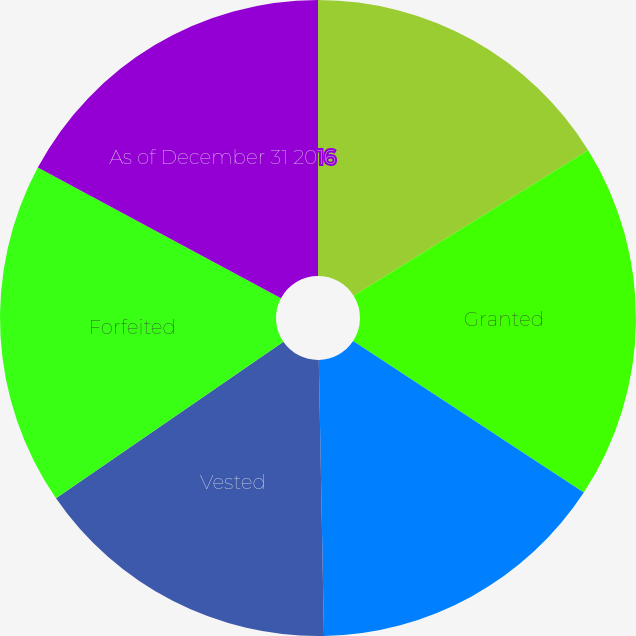Convert chart to OTSL. <chart><loc_0><loc_0><loc_500><loc_500><pie_chart><fcel>As of December 31 2015<fcel>Granted<fcel>Additional performance-based<fcel>Vested<fcel>Forfeited<fcel>As of December 31 2016<nl><fcel>16.16%<fcel>18.09%<fcel>15.45%<fcel>15.71%<fcel>17.43%<fcel>17.16%<nl></chart> 